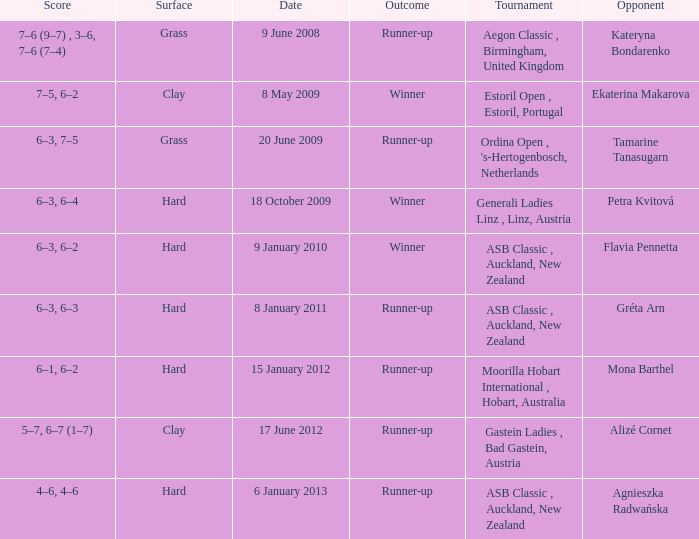What was the result of the match against ekaterina makarova in the tournament? 7–5, 6–2. 